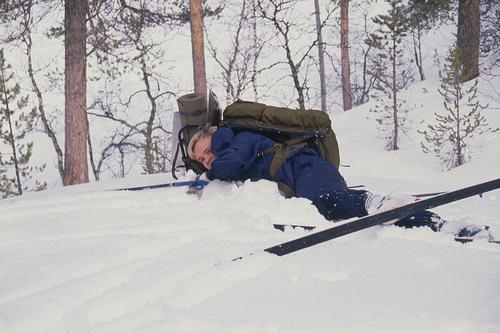How many people are there?
Give a very brief answer. 1. How many of his gloves are visible?
Give a very brief answer. 1. 